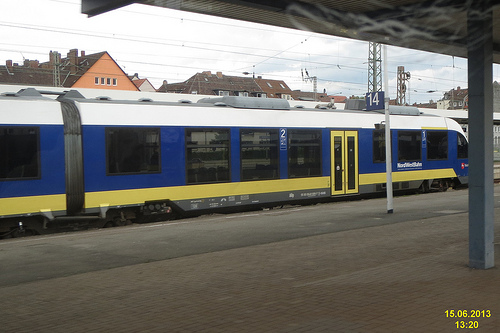How is the weather? The weather seems to be overcast, with a grey sky indicating cloud cover that might precede rain. 